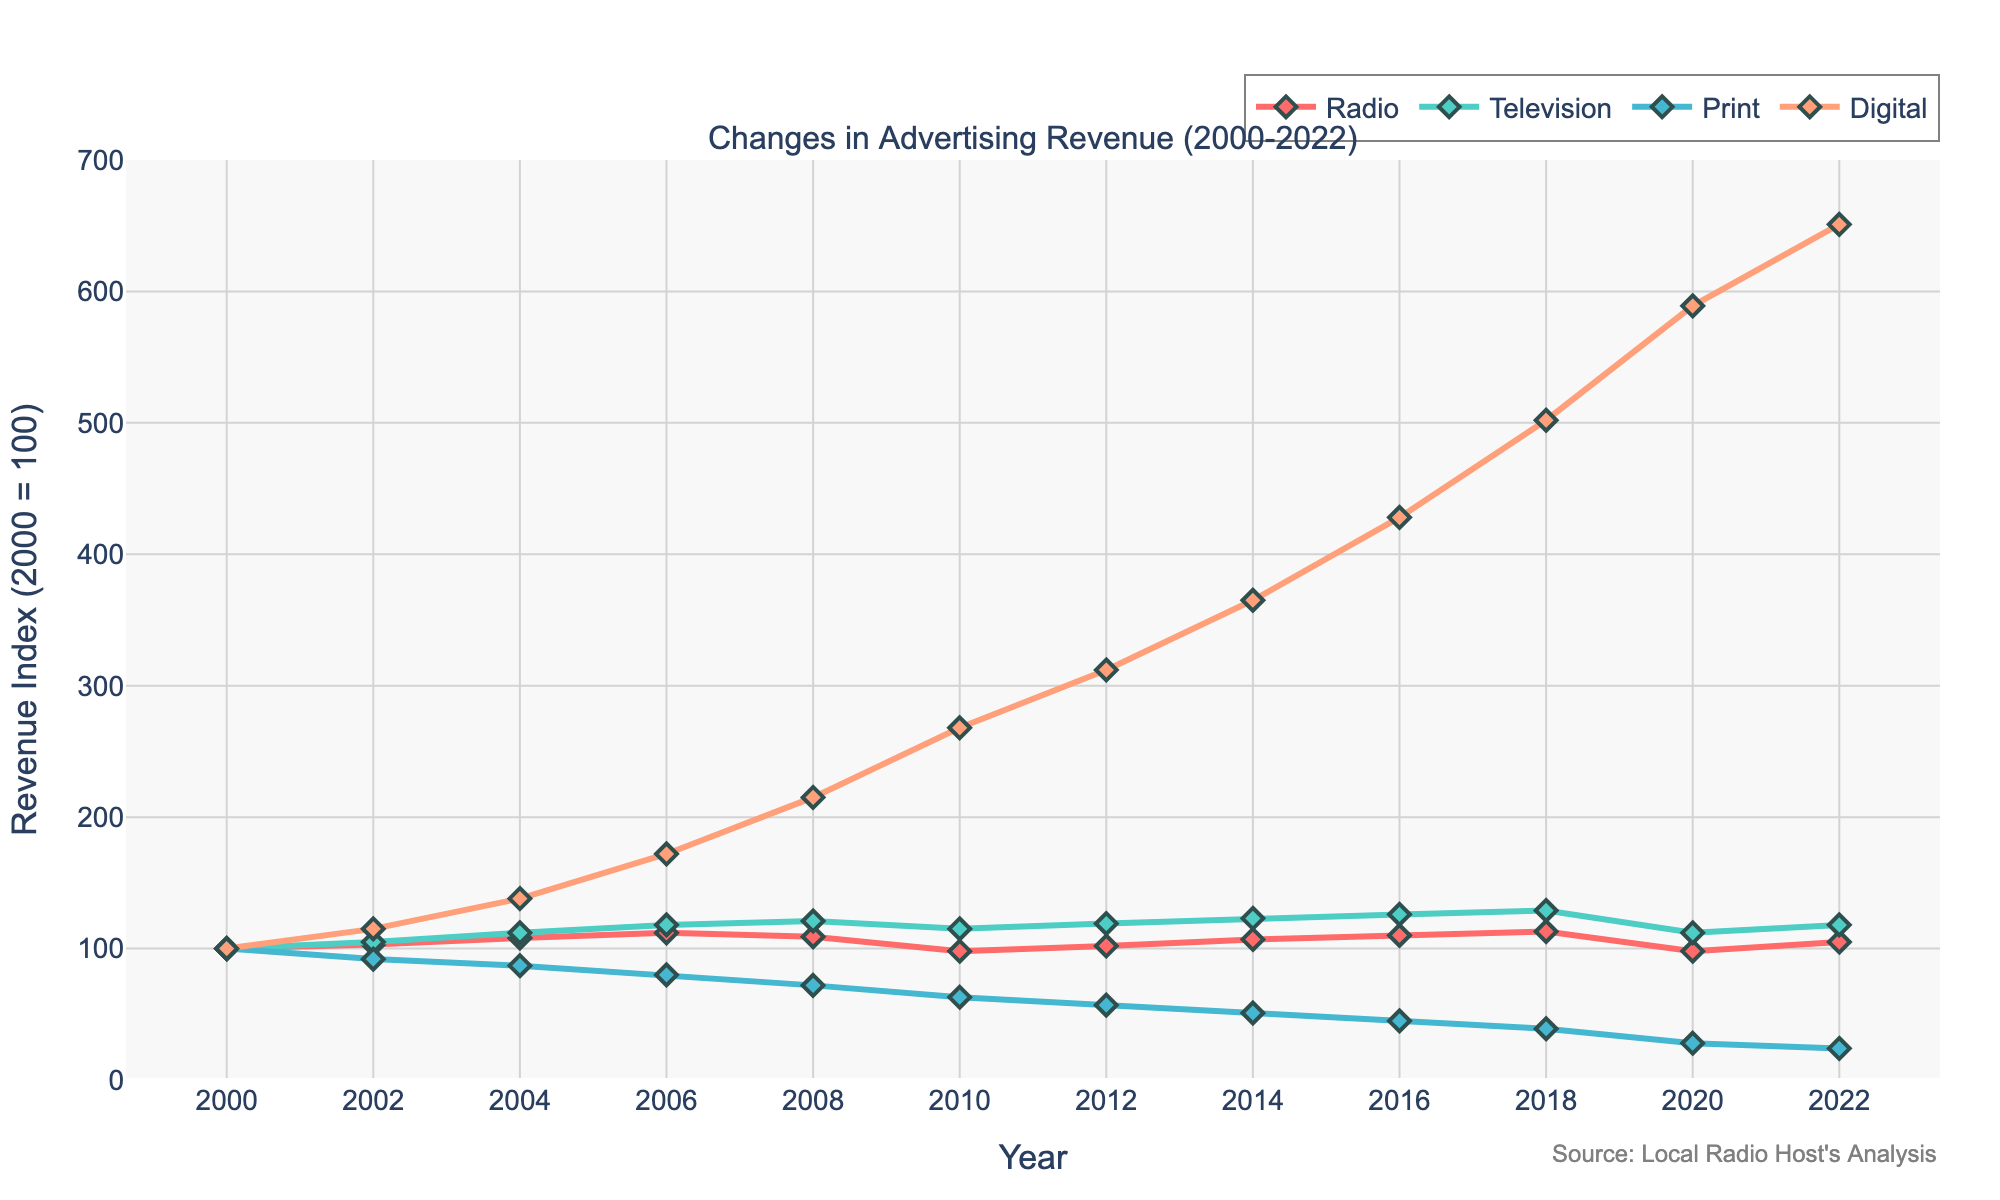What year did radio advertising revenue peak? According to the plot, the peak in radio advertising revenue is shown by the highest point on the radio line, which is around 2018 at an index of 113.
Answer: 2018 Which platform had the highest growth in advertising revenue from 2000 to 2022? The platform with the highest growth will have the highest point at the final year, 2022. Digital advertising shows the highest at 651.
Answer: Digital Between 2000 and 2022, which platform's advertising revenue decreased the most? To find the platform with the most significant decrease, observe which line drops the most from 2000 to 2022. Print media dropped from 100 to 24.
Answer: Print How does the revenue change for radio compare to television in 2010? For 2010, look at the values for both radio and television. Radio is 98, and television is 115. Television has a higher index than radio.
Answer: Television is higher What is the difference in advertising revenue index between digital and print platforms in 2022? For 2022, subtract the print revenue index (24) from the digital revenue index (651) to get the difference. 651 - 24 = 627.
Answer: 627 Which years did television advertising revenue surpass 120? Find the years where the television line crosses above the 120 mark. The years are 2008, 2014, 2016, and 2018.
Answer: 2008, 2014, 2016, 2018 Did radio advertising revenue ever fall below its value in 2000? Check if the radio revenue index fell below 100 anytime after 2000. Yes, it fell below 100 in 2010 and 2020.
Answer: Yes What was the trend in radio advertising revenue from 2000 to 2022? Observe the line representing radio advertising revenue from start to end. Initially, it increases, then decreases around 2010, fluctuates, and ends slightly above 2000 level at 105 in 2022.
Answer: Fluctuating with overall slight increase What was the average advertising revenue index for radio from 2000 to 2022? To calculate the average, sum the radio indices from all years and divide by the total number of years (12). (100+103+108+112+109+98+102+107+110+113+98+105) / 12 = 105.08.
Answer: 105.08 